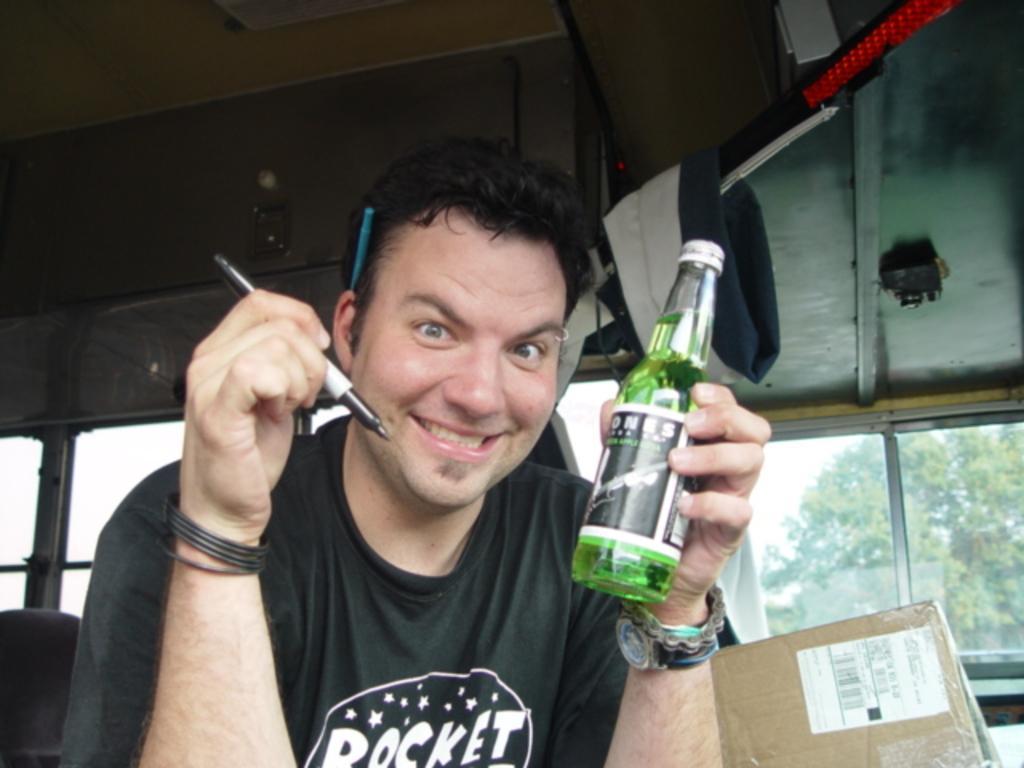Could you give a brief overview of what you see in this image? In this picture there is man sitting and holding a bottle in his left hand and a pen with his right hand and he is smiling. 